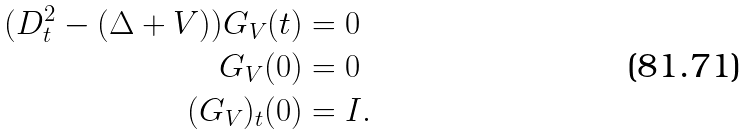<formula> <loc_0><loc_0><loc_500><loc_500>( D _ { t } ^ { 2 } - ( \Delta + V ) ) G _ { V } ( t ) & = 0 \\ G _ { V } ( 0 ) & = 0 \\ ( G _ { V } ) _ { t } ( 0 ) & = I .</formula> 